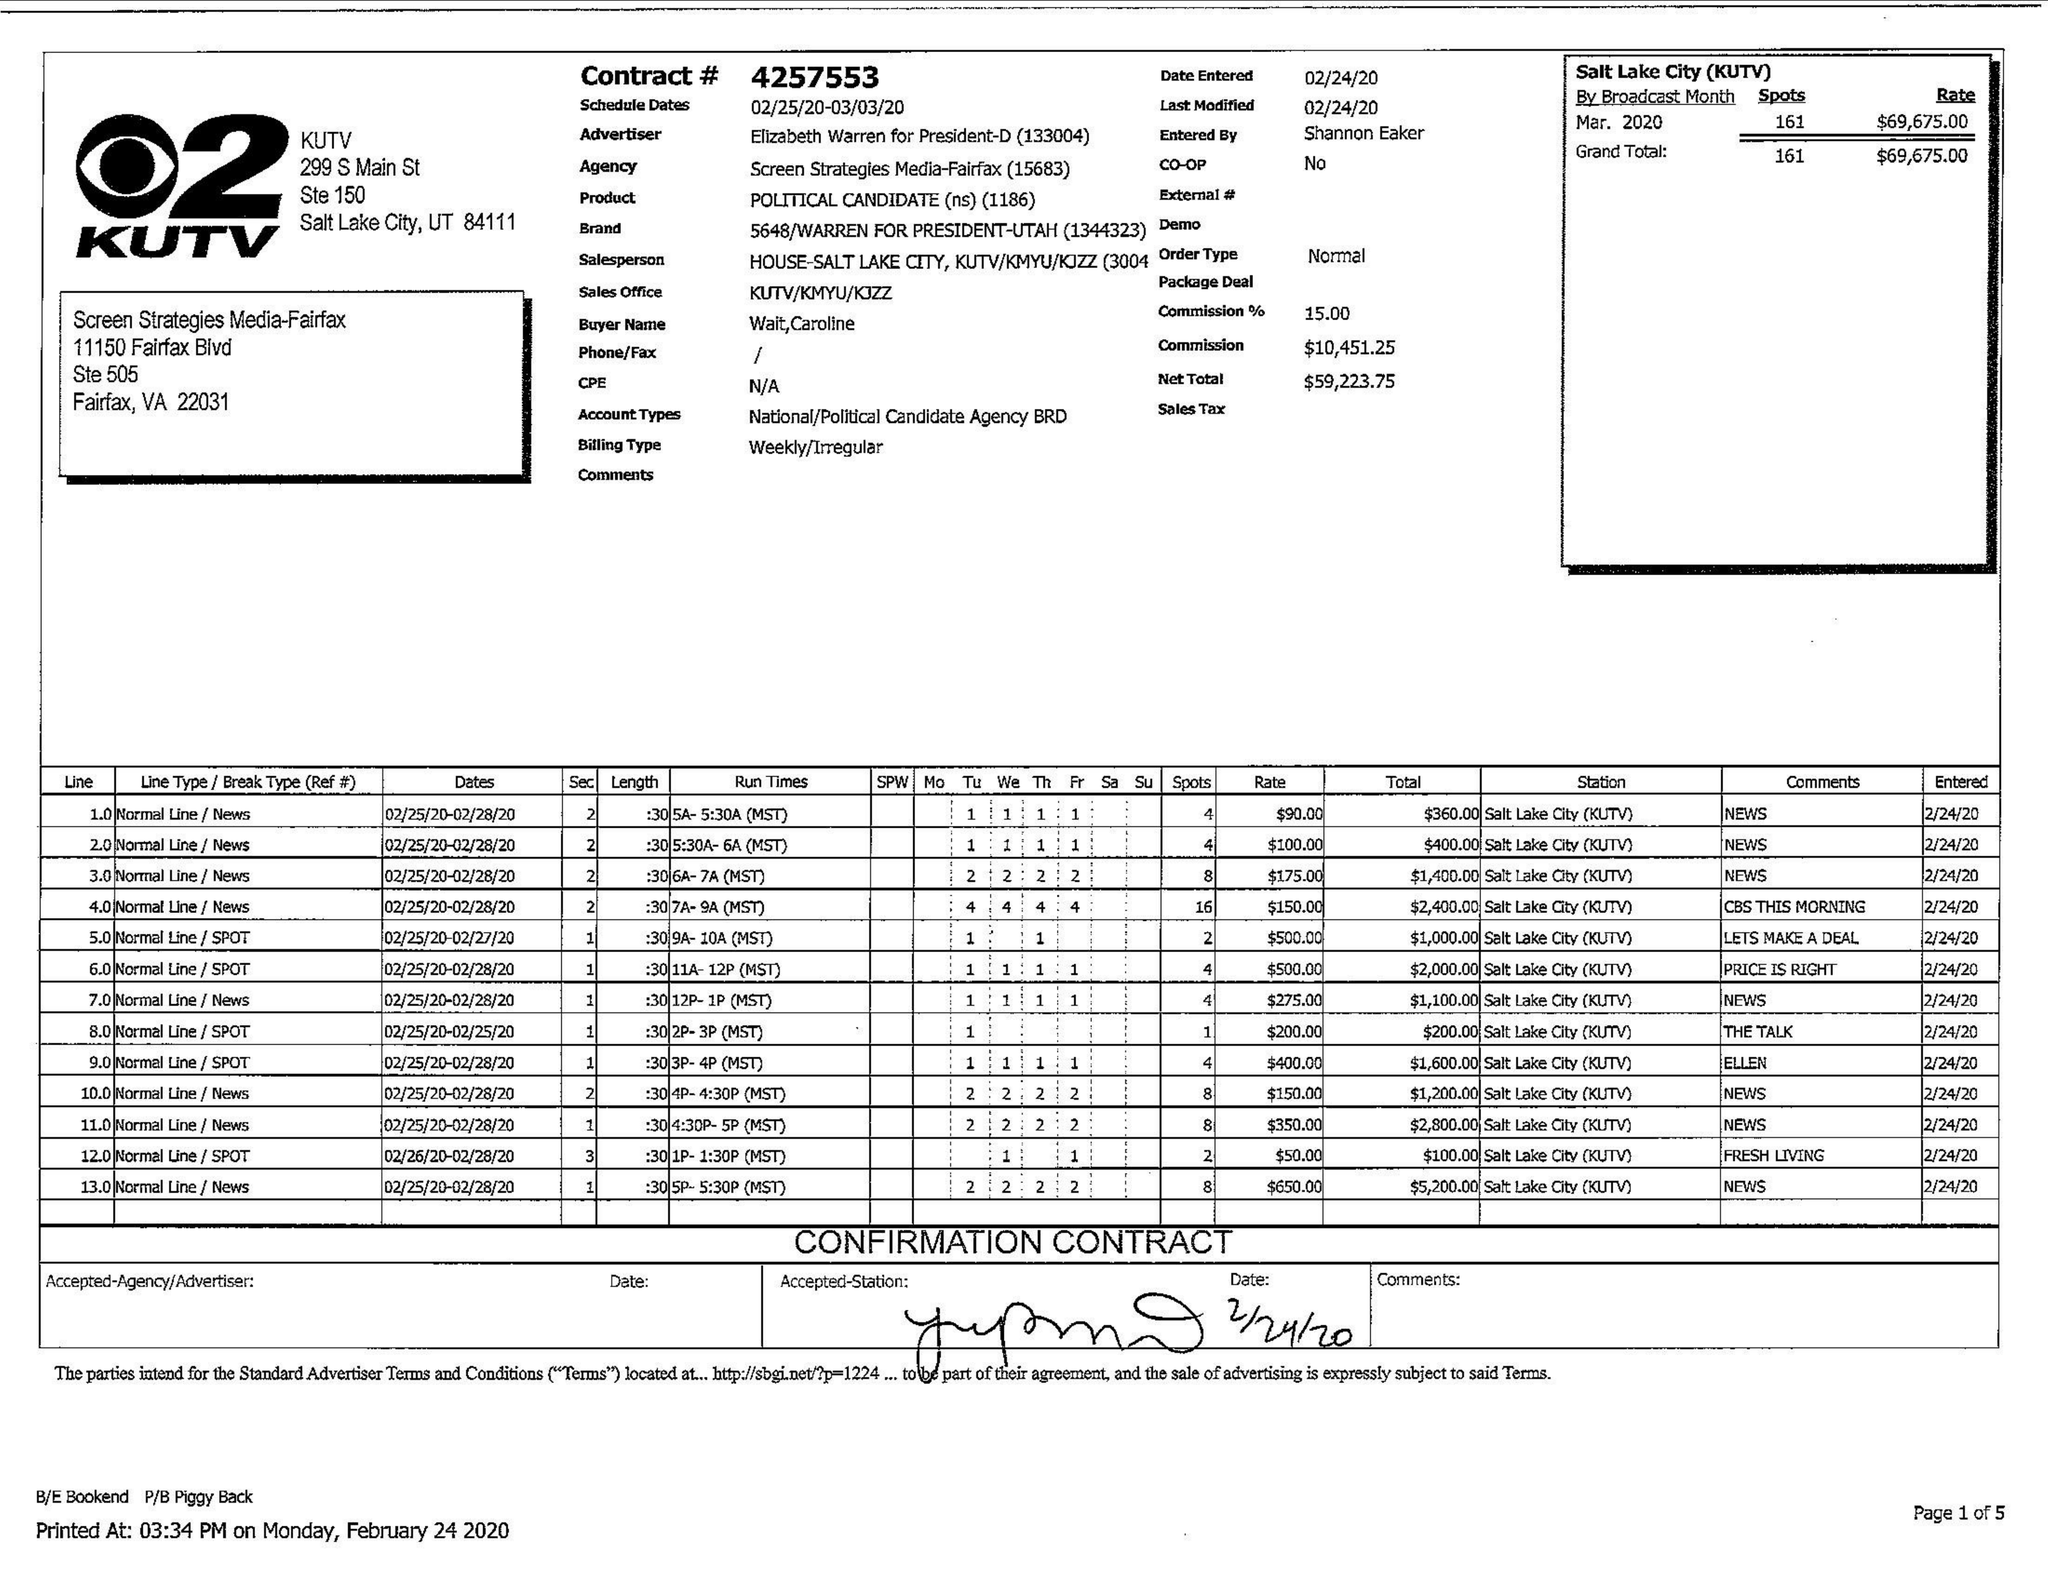What is the value for the contract_num?
Answer the question using a single word or phrase. 4257553 